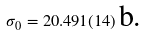<formula> <loc_0><loc_0><loc_500><loc_500>\sigma _ { 0 } = 2 0 . 4 9 1 ( 1 4 ) \, \text {b.}</formula> 